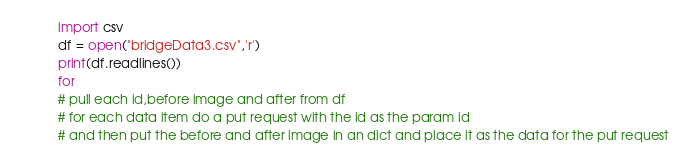<code> <loc_0><loc_0><loc_500><loc_500><_Python_>import csv
df = open("bridgeData3.csv",'r')
print(df.readlines())
for 
# pull each id,before image and after from df
# for each data item do a put request with the id as the param id 
# and then put the before and after image in an dict and place it as the data for the put request
</code> 